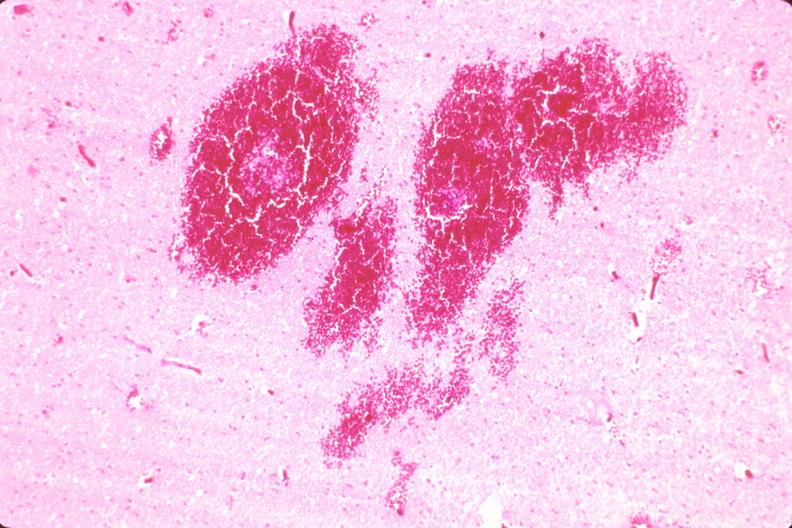what does this image show?
Answer the question using a single word or phrase. Brain 